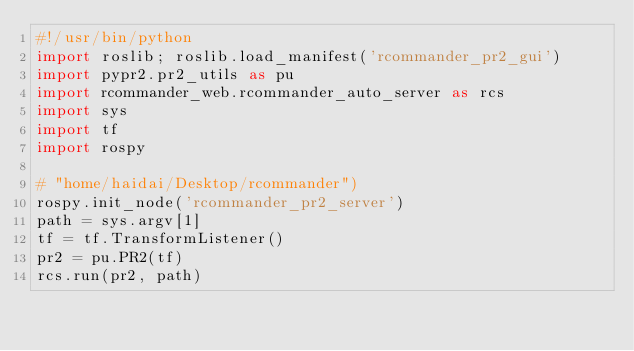Convert code to text. <code><loc_0><loc_0><loc_500><loc_500><_Python_>#!/usr/bin/python
import roslib; roslib.load_manifest('rcommander_pr2_gui')
import pypr2.pr2_utils as pu
import rcommander_web.rcommander_auto_server as rcs
import sys
import tf 
import rospy

# "home/haidai/Desktop/rcommander")
rospy.init_node('rcommander_pr2_server')
path = sys.argv[1]
tf = tf.TransformListener()
pr2 = pu.PR2(tf)
rcs.run(pr2, path)
</code> 